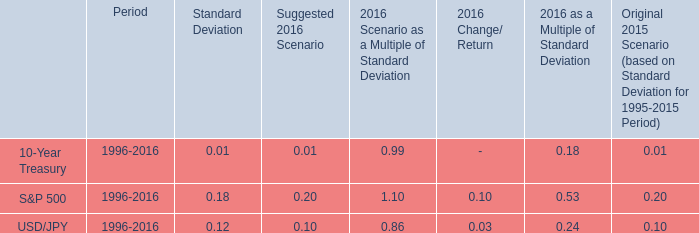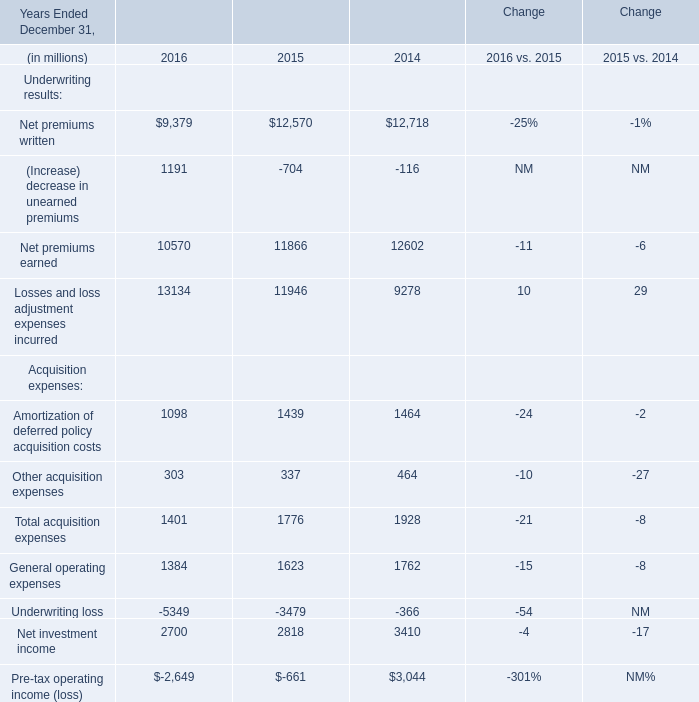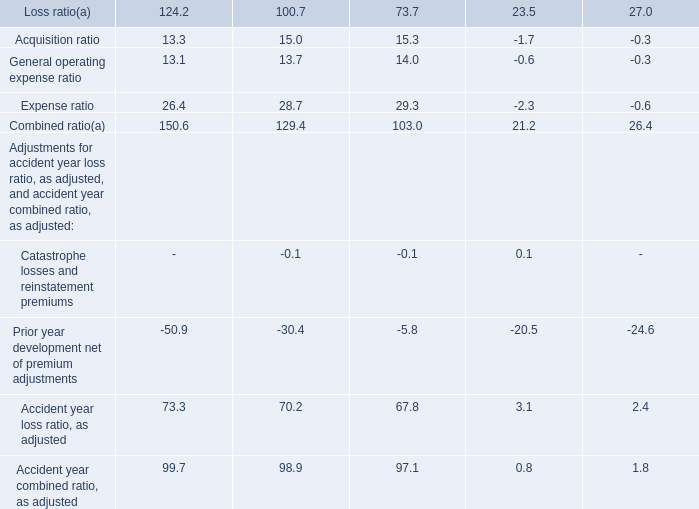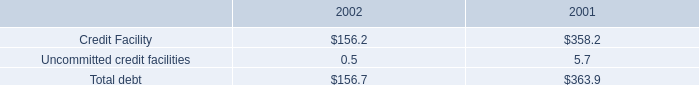What's the average of the Underwriting results in the years where (Increase) decrease in unearned premiums is positive? (in million) 
Computations: ((((9379 + 1191) + 10570) + 13134) / 4)
Answer: 8568.5. 